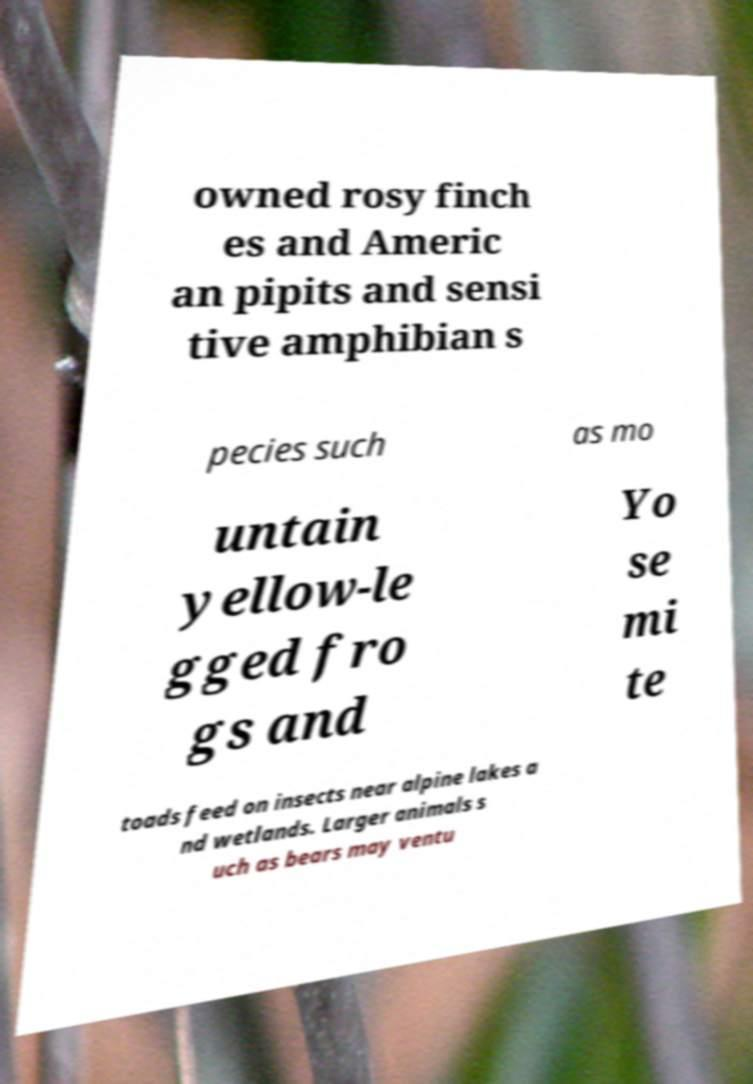I need the written content from this picture converted into text. Can you do that? owned rosy finch es and Americ an pipits and sensi tive amphibian s pecies such as mo untain yellow-le gged fro gs and Yo se mi te toads feed on insects near alpine lakes a nd wetlands. Larger animals s uch as bears may ventu 